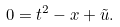Convert formula to latex. <formula><loc_0><loc_0><loc_500><loc_500>0 = t ^ { 2 } - x + \tilde { u } .</formula> 